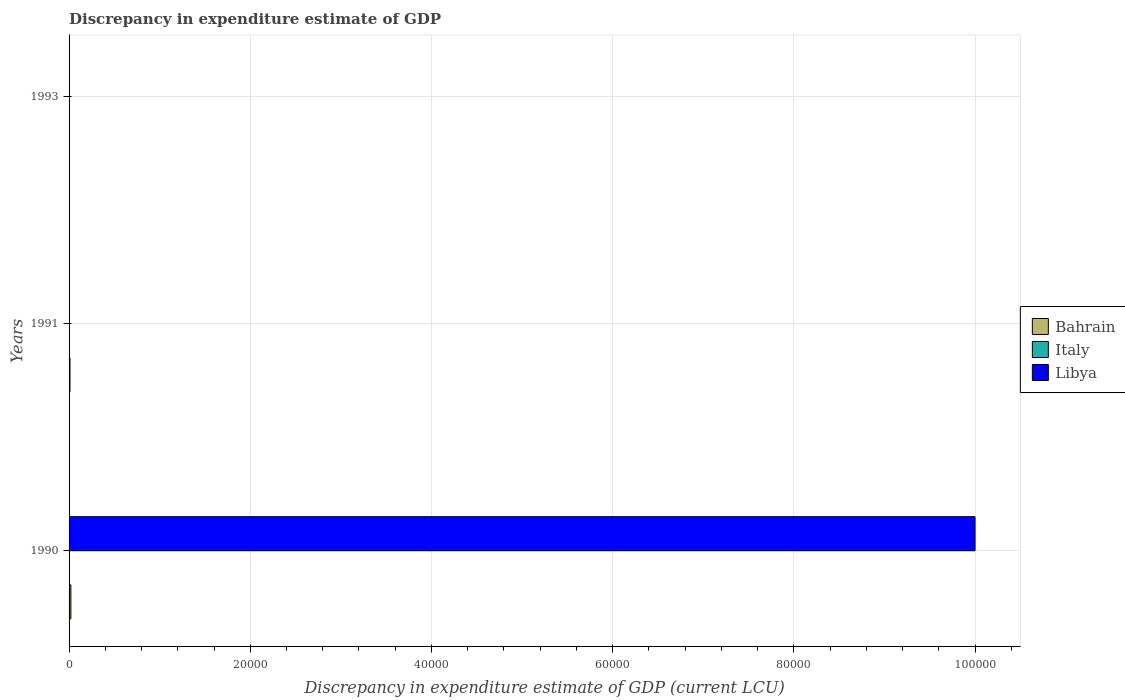Are the number of bars per tick equal to the number of legend labels?
Offer a terse response. No. How many bars are there on the 2nd tick from the top?
Give a very brief answer. 1. What is the label of the 1st group of bars from the top?
Ensure brevity in your answer.  1993. In how many cases, is the number of bars for a given year not equal to the number of legend labels?
Make the answer very short. 3. Across all years, what is the maximum discrepancy in expenditure estimate of GDP in Libya?
Offer a very short reply. 1.00e+05. What is the total discrepancy in expenditure estimate of GDP in Bahrain in the graph?
Make the answer very short. 300. What is the difference between the discrepancy in expenditure estimate of GDP in Bahrain in 1990 and that in 1991?
Ensure brevity in your answer.  100. What is the difference between the discrepancy in expenditure estimate of GDP in Italy in 1990 and the discrepancy in expenditure estimate of GDP in Bahrain in 1993?
Provide a short and direct response. 0. What is the average discrepancy in expenditure estimate of GDP in Bahrain per year?
Give a very brief answer. 100. In the year 1990, what is the difference between the discrepancy in expenditure estimate of GDP in Bahrain and discrepancy in expenditure estimate of GDP in Libya?
Offer a very short reply. -9.98e+04. In how many years, is the discrepancy in expenditure estimate of GDP in Libya greater than 48000 LCU?
Offer a terse response. 1. What is the difference between the highest and the lowest discrepancy in expenditure estimate of GDP in Bahrain?
Offer a terse response. 200. In how many years, is the discrepancy in expenditure estimate of GDP in Italy greater than the average discrepancy in expenditure estimate of GDP in Italy taken over all years?
Offer a terse response. 0. How many bars are there?
Your answer should be compact. 3. Are all the bars in the graph horizontal?
Give a very brief answer. Yes. Are the values on the major ticks of X-axis written in scientific E-notation?
Provide a succinct answer. No. How are the legend labels stacked?
Ensure brevity in your answer.  Vertical. What is the title of the graph?
Your answer should be compact. Discrepancy in expenditure estimate of GDP. What is the label or title of the X-axis?
Your response must be concise. Discrepancy in expenditure estimate of GDP (current LCU). What is the label or title of the Y-axis?
Ensure brevity in your answer.  Years. What is the Discrepancy in expenditure estimate of GDP (current LCU) of Bahrain in 1990?
Ensure brevity in your answer.  200. What is the Discrepancy in expenditure estimate of GDP (current LCU) in Libya in 1990?
Provide a succinct answer. 1.00e+05. What is the Discrepancy in expenditure estimate of GDP (current LCU) in Bahrain in 1991?
Make the answer very short. 100. What is the Discrepancy in expenditure estimate of GDP (current LCU) in Italy in 1991?
Your answer should be compact. 0. What is the Discrepancy in expenditure estimate of GDP (current LCU) in Libya in 1991?
Your answer should be compact. 0. What is the Discrepancy in expenditure estimate of GDP (current LCU) in Italy in 1993?
Offer a very short reply. 0. What is the Discrepancy in expenditure estimate of GDP (current LCU) of Libya in 1993?
Make the answer very short. 0. Across all years, what is the maximum Discrepancy in expenditure estimate of GDP (current LCU) in Bahrain?
Your answer should be very brief. 200. Across all years, what is the maximum Discrepancy in expenditure estimate of GDP (current LCU) in Libya?
Provide a short and direct response. 1.00e+05. Across all years, what is the minimum Discrepancy in expenditure estimate of GDP (current LCU) of Bahrain?
Your answer should be compact. 0. What is the total Discrepancy in expenditure estimate of GDP (current LCU) of Bahrain in the graph?
Your response must be concise. 300. What is the total Discrepancy in expenditure estimate of GDP (current LCU) of Libya in the graph?
Provide a short and direct response. 1.00e+05. What is the difference between the Discrepancy in expenditure estimate of GDP (current LCU) of Bahrain in 1990 and that in 1991?
Offer a very short reply. 100. What is the average Discrepancy in expenditure estimate of GDP (current LCU) of Italy per year?
Your answer should be very brief. 0. What is the average Discrepancy in expenditure estimate of GDP (current LCU) in Libya per year?
Give a very brief answer. 3.33e+04. In the year 1990, what is the difference between the Discrepancy in expenditure estimate of GDP (current LCU) of Bahrain and Discrepancy in expenditure estimate of GDP (current LCU) of Libya?
Your answer should be compact. -9.98e+04. What is the ratio of the Discrepancy in expenditure estimate of GDP (current LCU) in Bahrain in 1990 to that in 1991?
Keep it short and to the point. 2. What is the difference between the highest and the lowest Discrepancy in expenditure estimate of GDP (current LCU) in Libya?
Make the answer very short. 1.00e+05. 